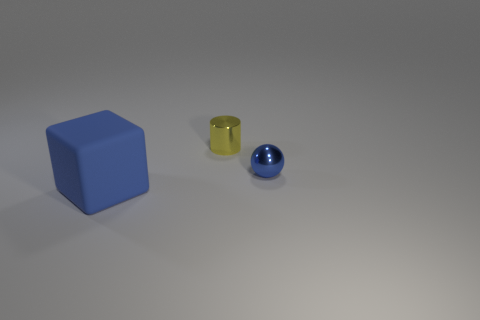Add 1 big blue rubber cubes. How many objects exist? 4 Subtract all cylinders. How many objects are left? 2 Add 1 blue matte blocks. How many blue matte blocks are left? 2 Add 2 tiny gray balls. How many tiny gray balls exist? 2 Subtract 0 red spheres. How many objects are left? 3 Subtract all tiny green blocks. Subtract all large matte cubes. How many objects are left? 2 